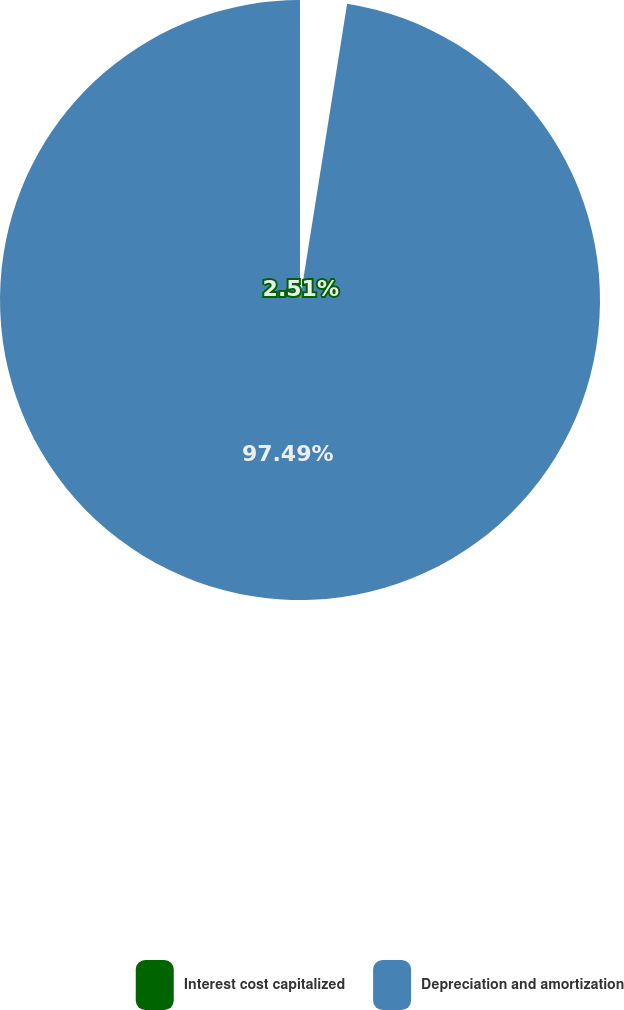Convert chart to OTSL. <chart><loc_0><loc_0><loc_500><loc_500><pie_chart><fcel>Interest cost capitalized<fcel>Depreciation and amortization<nl><fcel>2.51%<fcel>97.49%<nl></chart> 